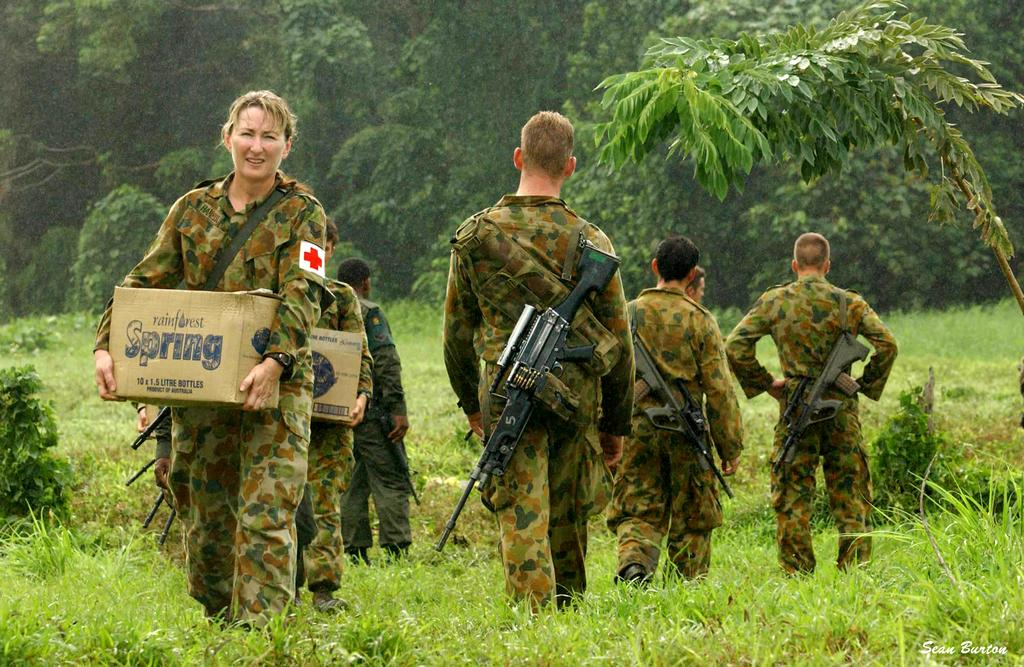What is the main subject of the image? There is a group of soldiers in the image. What can be seen around the soldiers? There is a lot of grass around the soldiers. What is visible in the background of the image? There are trees in the background of the image. Can you tell me how the zephyr is affecting the soldiers in the image? There is no mention of a zephyr or any wind in the image, so we cannot determine its effect on the soldiers. Are there any monkeys present in the image? There are no monkeys visible in the image; it features a group of soldiers and a grassy environment. 